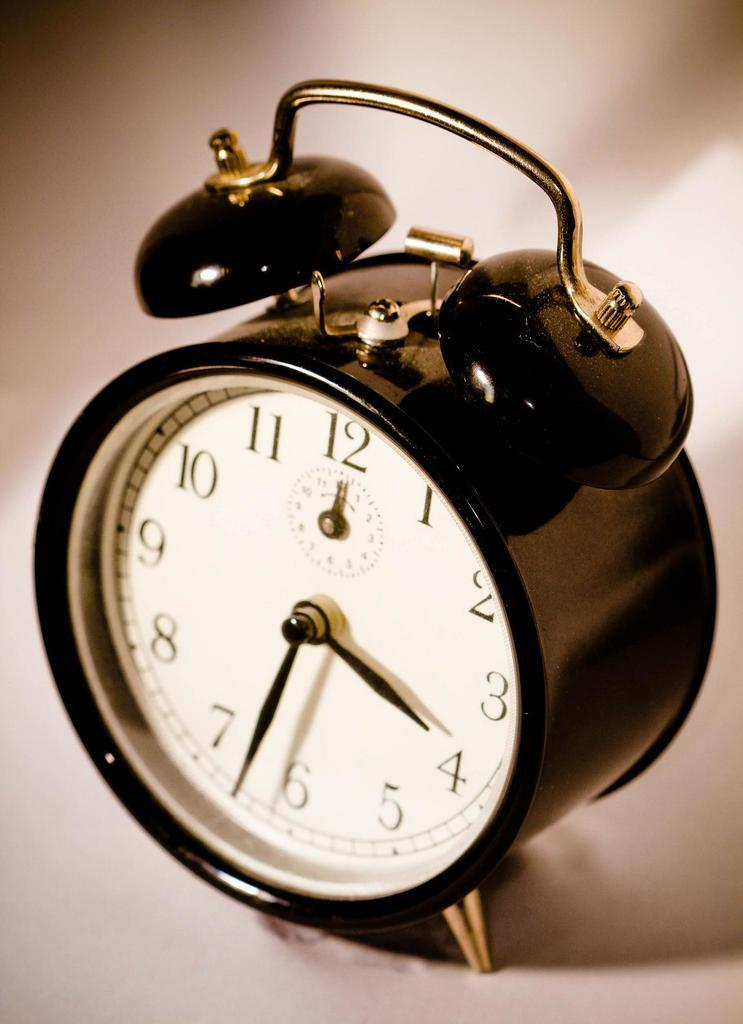<image>
Write a terse but informative summary of the picture. An old clock which shows the time at around 4:32 